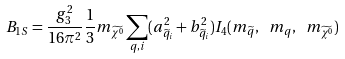Convert formula to latex. <formula><loc_0><loc_0><loc_500><loc_500>B _ { 1 S } = \frac { g ^ { 2 } _ { 3 } } { 1 6 \pi ^ { 2 } } \frac { 1 } { 3 } m _ { \widetilde { \chi ^ { 0 } } } \sum _ { q , i } ( a ^ { 2 } _ { \widetilde { q } _ { i } } + b ^ { 2 } _ { \widetilde { q } _ { i } } ) I _ { 4 } ( m _ { \widetilde { q } } , \ m _ { q } , \ m _ { \widetilde { \chi ^ { 0 } } } )</formula> 